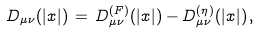<formula> <loc_0><loc_0><loc_500><loc_500>D _ { \mu \nu } ( | x | ) \, = \, D _ { \mu \nu } ^ { ( F ) } ( | x | ) - D _ { \mu \nu } ^ { ( \eta ) } ( | x | ) \, ,</formula> 